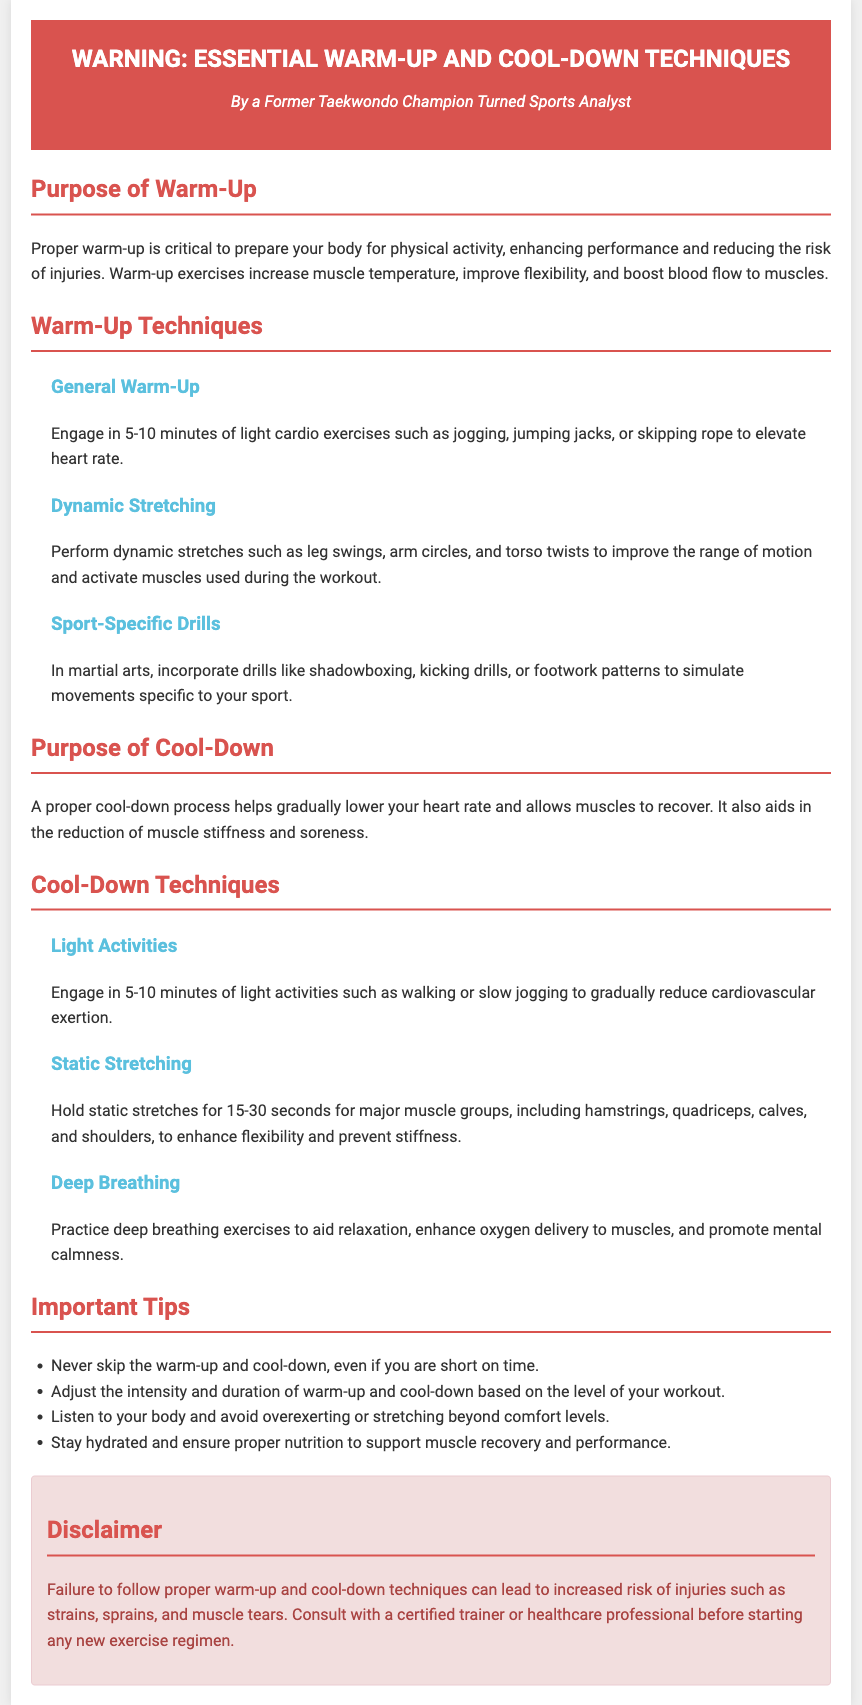What is the purpose of warm-up? The purpose is to prepare the body for physical activity, enhancing performance and reducing the risk of injuries.
Answer: Prepare body for physical activity How long should you perform light cardio exercises during warm-up? The document states that 5-10 minutes of light cardio exercises should be engaged in.
Answer: 5-10 minutes What is an example of a dynamic stretching exercise? The document lists leg swings, arm circles, and torso twists as examples of dynamic stretching exercises.
Answer: Leg swings What are two major benefits of proper cool-down? According to the document, a proper cool-down helps reduce muscle stiffness and soreness, as well as gradually lower heart rate.
Answer: Reduce stiffness and soreness What should you never skip regardless of time constraints? The document explicitly states that warm-up and cool-down should never be skipped.
Answer: Warm-up and cool-down How long should static stretches be held? The document mentions holding static stretches for 15-30 seconds for major muscle groups.
Answer: 15-30 seconds What is one tip for listening to your body during exercise? The document advises to avoid overexerting or stretching beyond comfort levels when listening to your body.
Answer: Avoid overexerting Who should you consult before starting a new exercise regimen? The document recommends consulting with a certified trainer or healthcare professional.
Answer: Certified trainer or healthcare professional What color is the header of the warning label? The header of the warning label is colored in red (#d9534f).
Answer: Red 